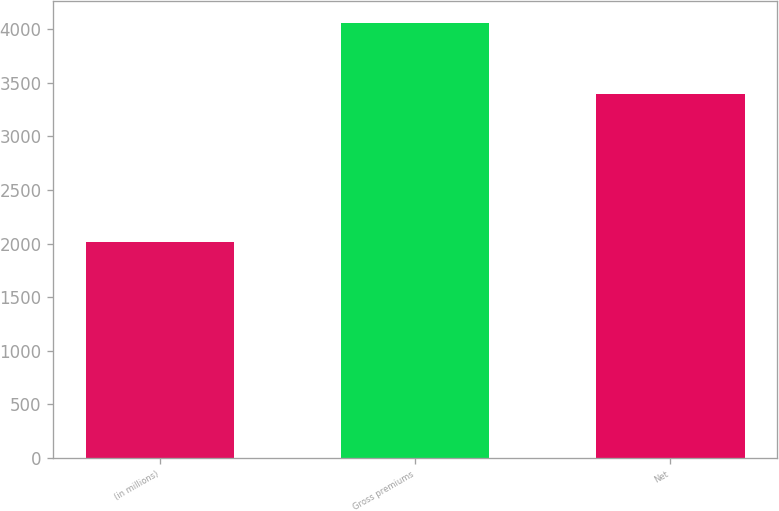Convert chart to OTSL. <chart><loc_0><loc_0><loc_500><loc_500><bar_chart><fcel>(in millions)<fcel>Gross premiums<fcel>Net<nl><fcel>2014<fcel>4059<fcel>3398<nl></chart> 